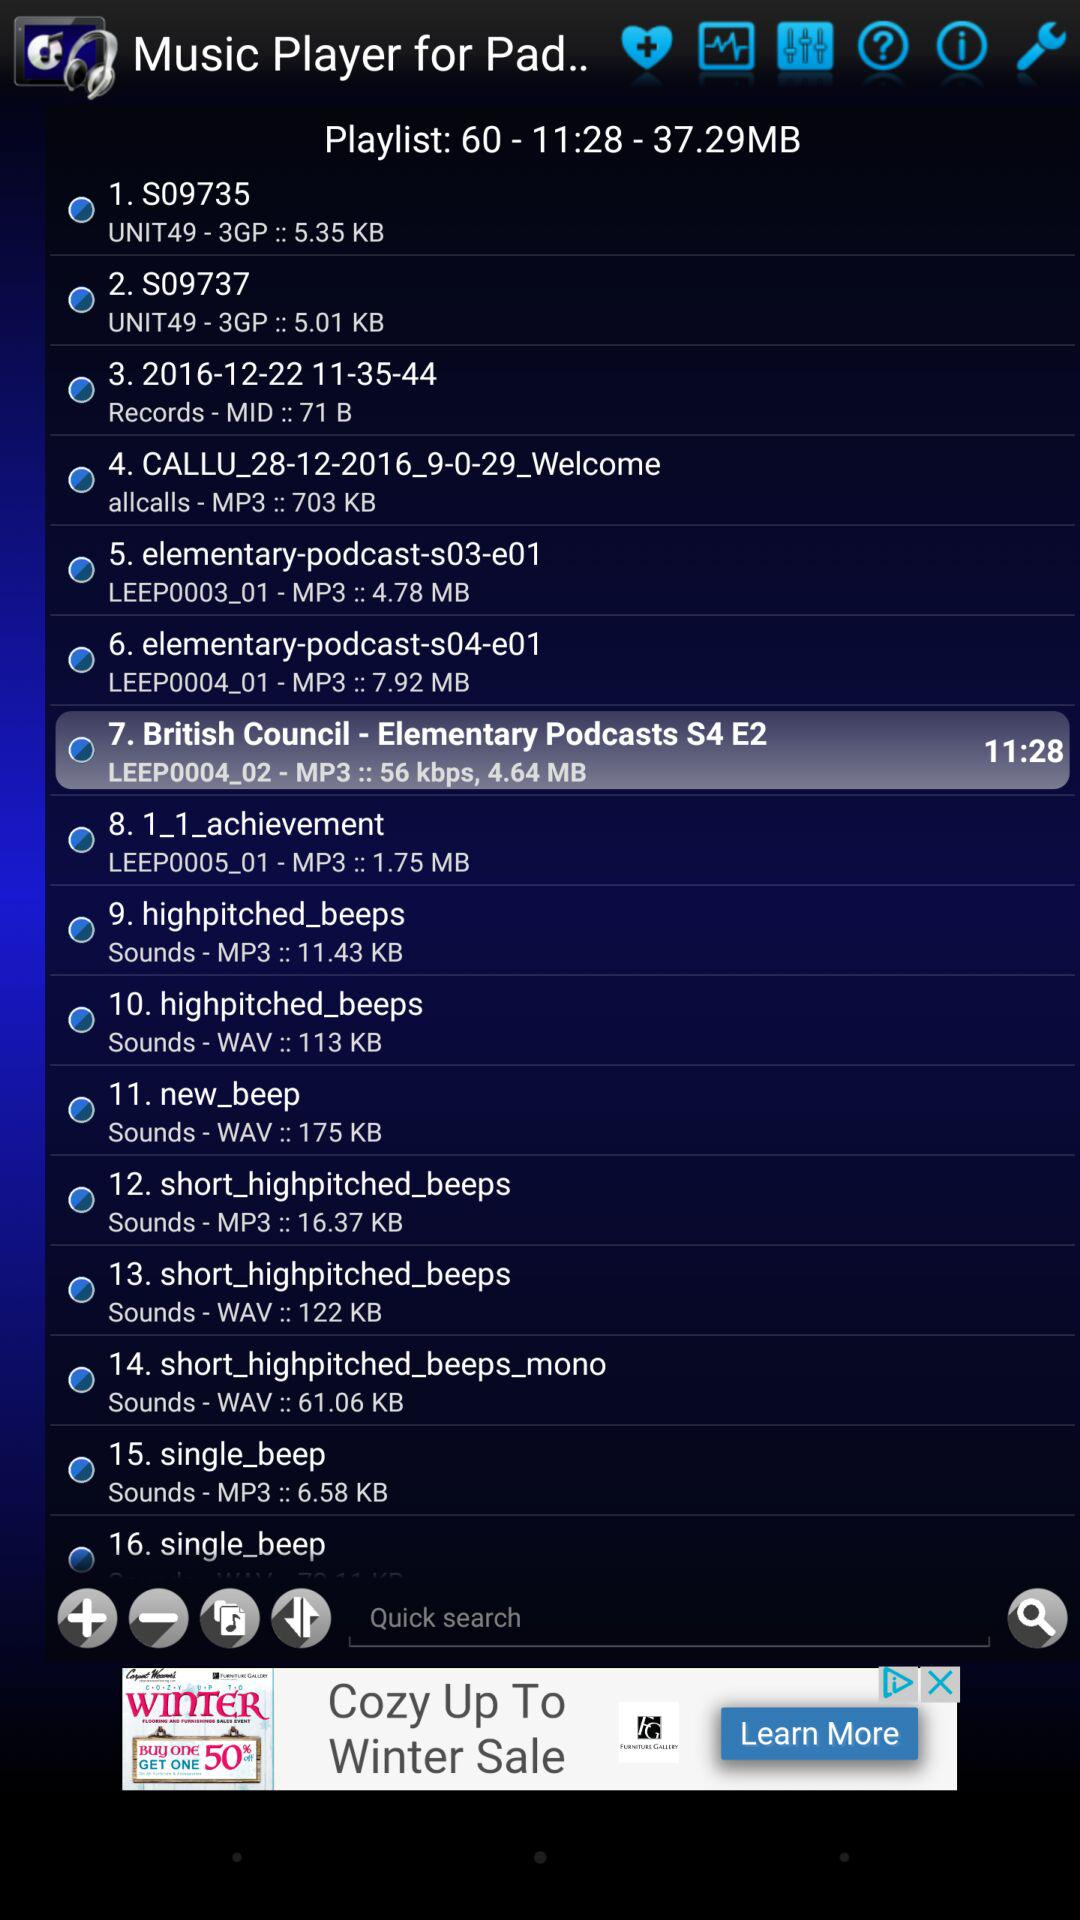What's the file size of "6. elementary-podcast-s04-e01"? The file size is 7.92 MB. 